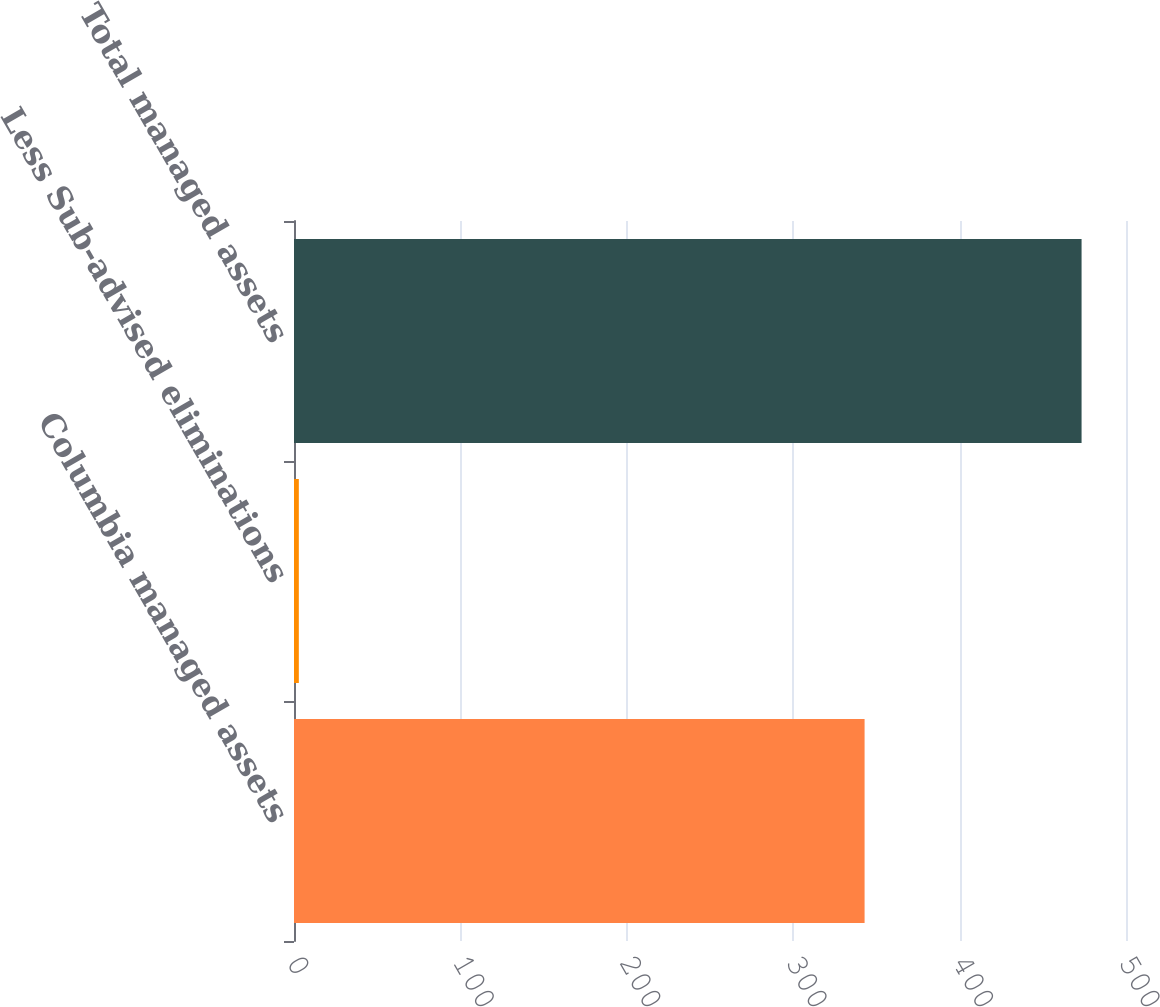Convert chart to OTSL. <chart><loc_0><loc_0><loc_500><loc_500><bar_chart><fcel>Columbia managed assets<fcel>Less Sub-advised eliminations<fcel>Total managed assets<nl><fcel>342.9<fcel>2.9<fcel>473.3<nl></chart> 